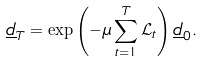Convert formula to latex. <formula><loc_0><loc_0><loc_500><loc_500>\underline { d } _ { T } = \exp \left ( - \mu \sum _ { t = 1 } ^ { T } \mathcal { L } _ { t } \right ) \underline { d } _ { 0 } .</formula> 